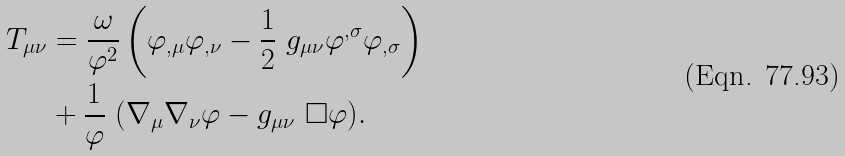Convert formula to latex. <formula><loc_0><loc_0><loc_500><loc_500>T _ { \mu \nu } & = \frac { \omega } { \varphi ^ { 2 } } \left ( \varphi _ { , \mu } \varphi _ { , \nu } - \frac { 1 } { 2 } \ g _ { \mu \nu } \varphi ^ { , \sigma } \varphi _ { , \sigma } \right ) \\ & + \frac { 1 } { \varphi } \ ( \nabla _ { \mu } \nabla _ { \nu } \varphi - g _ { \mu \nu } \ \Box \varphi ) .</formula> 